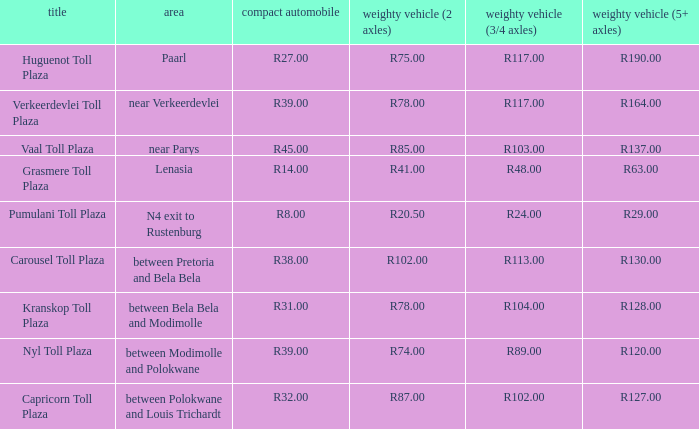What is the name of the plaza where the told for heavy vehicles with 2 axles is r20.50? Pumulani Toll Plaza. 